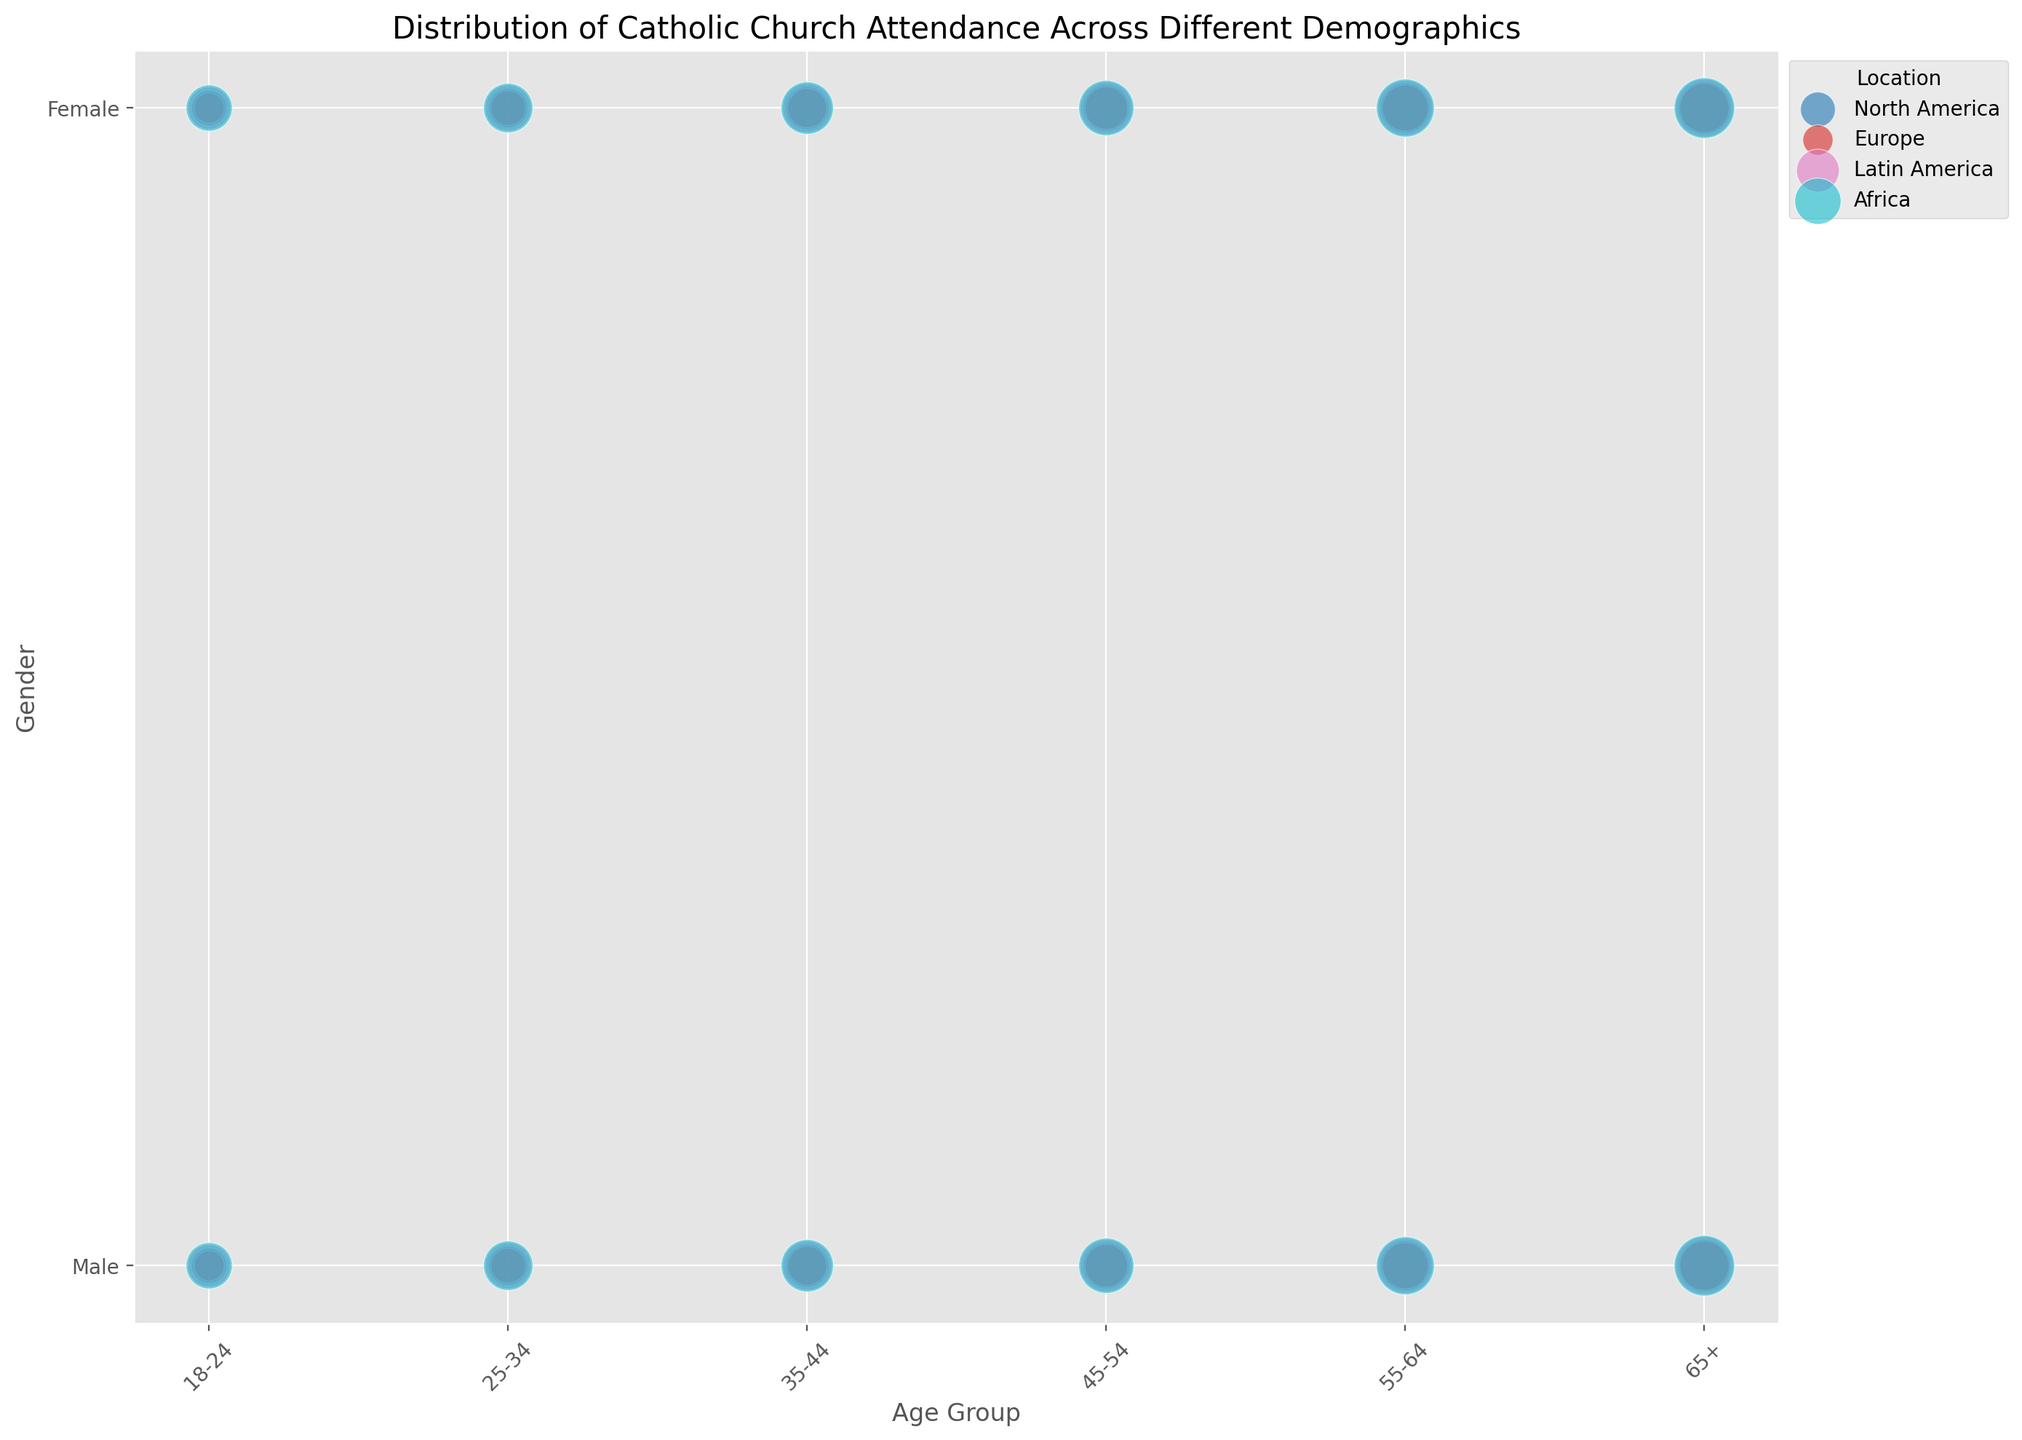Which age group and gender has the highest attendance percentage in North America? In North America, look at the scatter points to see the size of the bubbles, which denotes the attendance percentage. The largest bubble corresponds to the age group "65+" and gender "Female".
Answer: 65+ Female How does the attendance percentage for 25-34 males in Africa compare with 55-64 males in Europe? The attendance percentage for 25-34 males in Africa can be seen as a scatter point with a relatively large bubble, which is 35%. Meanwhile, the bubble size for 55-64 males in Europe is slightly smaller, denoting 24%. Therefore, the attendance percentage is higher in Africa for 25-34 males.
Answer: 35% is greater than 24% What is the difference in attendance percentage between 65+ males and 65+ females in Latin America? The attendance percentage for 65+ males in Latin America is 50%, and for females, it is 52%. By calculating the difference, we get 52% - 50% = 2%.
Answer: 2% Identify the location with the most balanced attendance between males and females across all age groups. Observing the balance between bubble sizes representing males and females across age groups, Africa shows the least disparity as both male and female bubbles are relatively close in size.
Answer: Africa Which age group has the lowest attendance percentage in Europe? By comparing bubble sizes in Europe, the smallest bubble is for the age group 18-24 males, corresponding to an attendance percentage of 10%.
Answer: 18-24 males In which location do 35-44 females have the highest attendance percentage? Comparing the bubble sizes for the age group 35-44 females across all locations, Africa has the largest bubble with an attendance of 43%.
Answer: Africa What is the combined attendance percentage for 18-24 females across all given locations? The attendance percentages for 18-24 females are 18% (North America), 12% (Europe), 27% (Latin America), and 33% (Africa). Adding these, we get 18 + 12 + 27 + 33 = 90%.
Answer: 90% How does the attendance percentage for 45-54 females compare between North America and Latin America? The attendance percentage for 45-54 females in North America is 32%, and in Latin America, it is 42%. Therefore, the attendance percentage in Latin America is greater.
Answer: 42% is greater than 32% Which gender within the age group 55-64 has the highest average attendance across all locations? Compute the average for males and females within 55-64 across locations. For males: (35+24+45+50)/4 = 38.5%. For females: (38+26+47+53)/4 = 41%. Thus, females have a higher average attendance.
Answer: Females, 41% What is the largest bubble size, and which demographic does it represent? The largest bubble corresponds to "65+" females in Africa, indicating a demographic size of 60.
Answer: 65+ females in Africa 60 